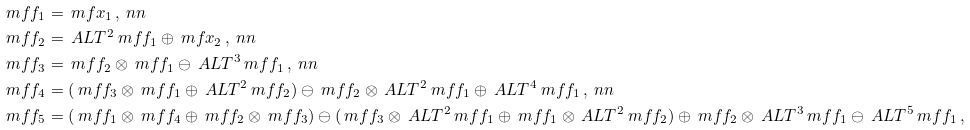Convert formula to latex. <formula><loc_0><loc_0><loc_500><loc_500>\ m f { f } _ { 1 } & = \ m f { x } _ { 1 } \, , \ n n \\ \ m f { f } _ { 2 } & = \ A L T ^ { 2 } \ m f { f } _ { 1 } \oplus \ m f { x } _ { 2 } \, , \ n n \\ \ m f { f } _ { 3 } & = \ m f { f } _ { 2 } \otimes \ m f { f } _ { 1 } \ominus \ A L T ^ { 3 } \ m f { f } _ { 1 } \, , \ n n \\ \ m f { f } _ { 4 } & = ( \ m f { f } _ { 3 } \otimes \ m f { f } _ { 1 } \oplus \ A L T ^ { 2 } \ m f { f } _ { 2 } ) \ominus \ m f { f } _ { 2 } \otimes \ A L T ^ { 2 } \ m f { f } _ { 1 } \oplus \ A L T ^ { 4 } \ m f { f } _ { 1 } \, , \ n n \\ \ m f { f } _ { 5 } & = ( \ m f { f } _ { 1 } \otimes \ m f { f } _ { 4 } \oplus \ m f { f } _ { 2 } \otimes \ m f { f } _ { 3 } ) \ominus ( \ m f { f } _ { 3 } \otimes \ A L T ^ { 2 } \ m f { f } _ { 1 } \oplus \ m f { f } _ { 1 } \otimes \ A L T ^ { 2 } \ m f { f } _ { 2 } ) \oplus \ m f { f } _ { 2 } \otimes \ A L T ^ { 3 } \ m f { f } _ { 1 } \ominus \ A L T ^ { 5 } \ m f { f } _ { 1 } \, ,</formula> 